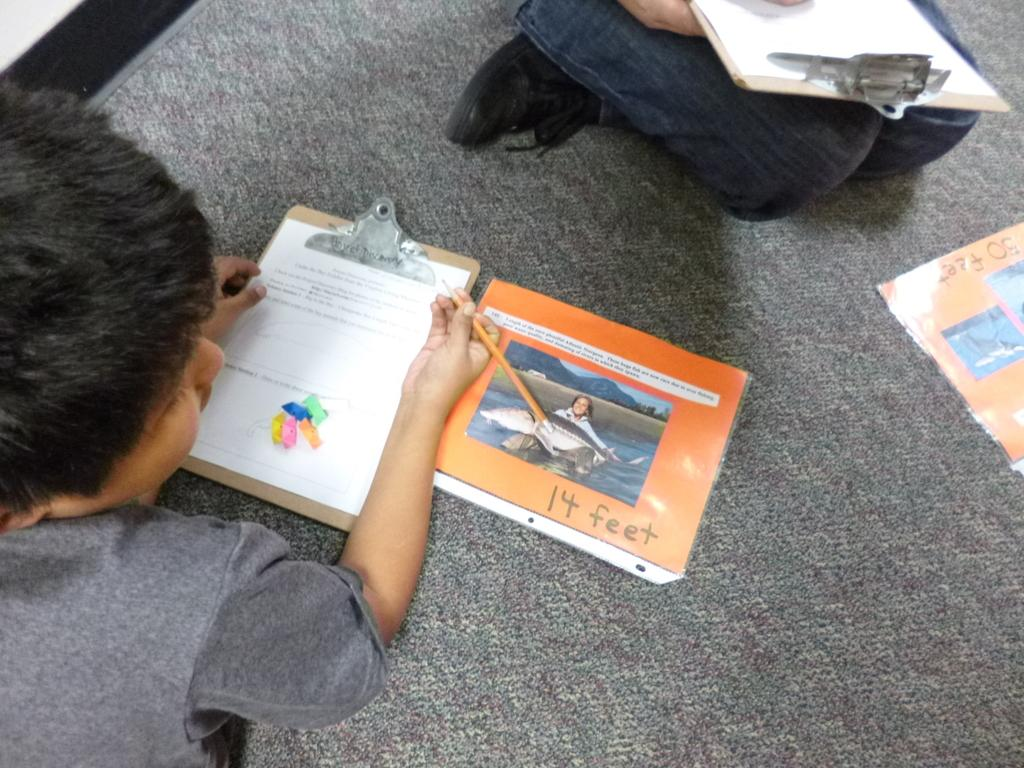How many people are sitting on the floor in the image? There are two persons sitting on the floor in the image. What objects are in front of the persons? There are papers, a pencil, and a book in front of the persons. What might the persons be doing with the objects in front of them? The persons might be working on the papers using the pencil and book. What type of jar can be seen in the image? There is no jar present in the image. Can you describe the net that is being used by the persons in the image? There is no net present in the image; the persons are working with papers, a pencil, and a book. 